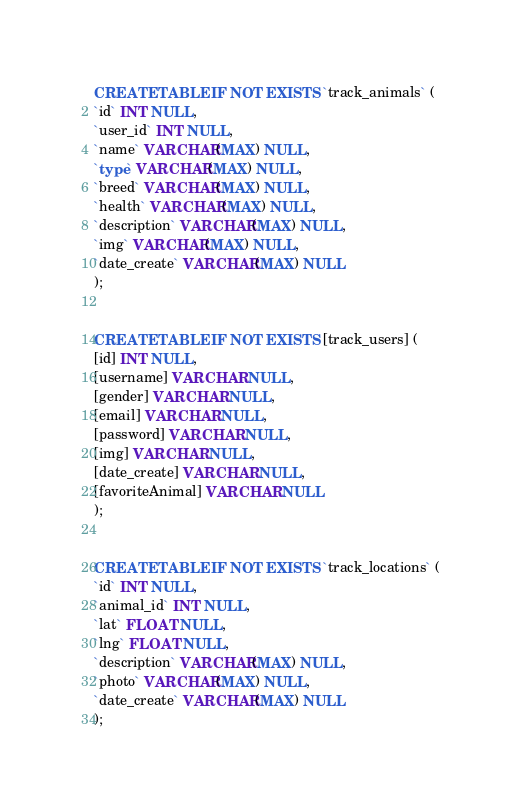Convert code to text. <code><loc_0><loc_0><loc_500><loc_500><_SQL_>CREATE TABLE IF NOT EXISTS `track_animals` (
`id` INT NULL,
`user_id` INT NULL,
`name` VARCHAR(MAX) NULL,
`type` VARCHAR(MAX) NULL,
`breed` VARCHAR(MAX) NULL,
`health` VARCHAR(MAX) NULL,
`description` VARCHAR(MAX) NULL,
`img` VARCHAR(MAX) NULL,
`date_create` VARCHAR(MAX) NULL
);


CREATE TABLE IF NOT EXISTS [track_users] (
[id] INT NULL,
[username] VARCHAR NULL,
[gender] VARCHAR NULL,
[email] VARCHAR NULL,
[password] VARCHAR NULL,
[img] VARCHAR NULL,
[date_create] VARCHAR NULL,
[favoriteAnimal] VARCHAR NULL
);


CREATE TABLE IF NOT EXISTS `track_locations` (
`id` INT NULL,
`animal_id` INT NULL,
`lat` FLOAT NULL,
`lng` FLOAT NULL,
`description` VARCHAR(MAX) NULL,
`photo` VARCHAR(MAX) NULL,
`date_create` VARCHAR(MAX) NULL
);</code> 